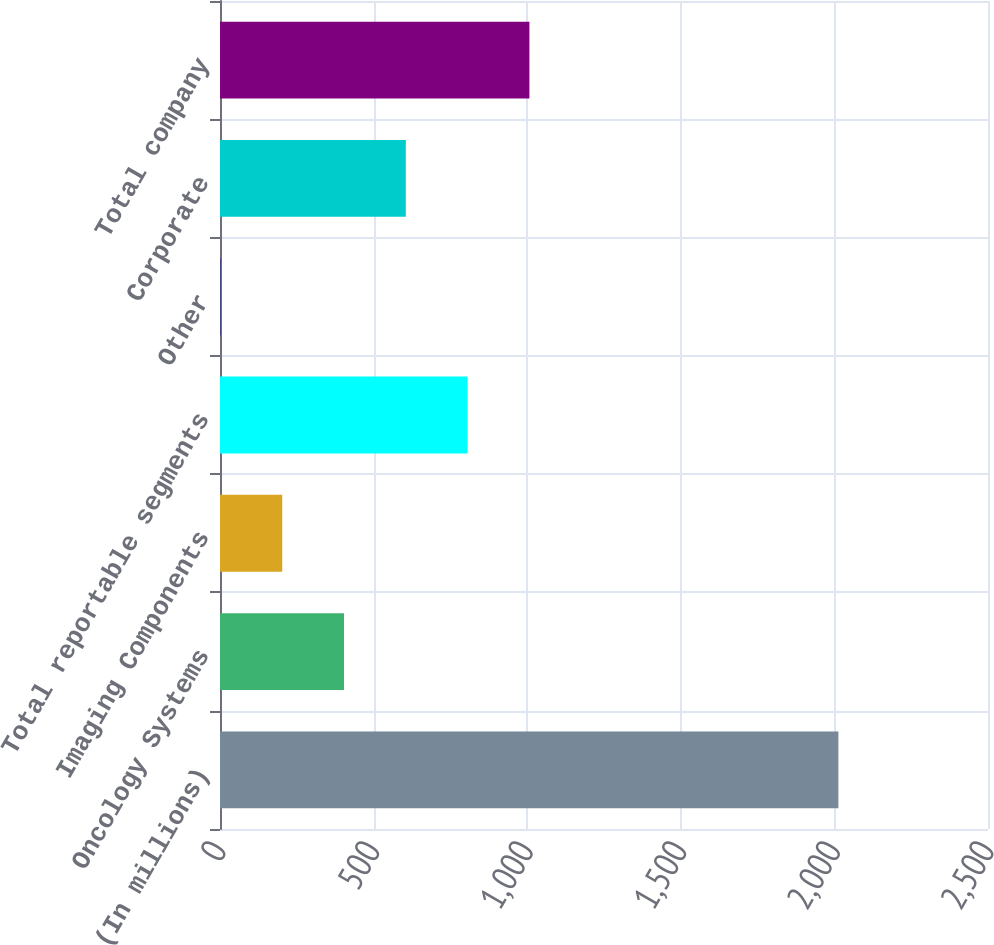Convert chart. <chart><loc_0><loc_0><loc_500><loc_500><bar_chart><fcel>(In millions)<fcel>Oncology Systems<fcel>Imaging Components<fcel>Total reportable segments<fcel>Other<fcel>Corporate<fcel>Total company<nl><fcel>2013<fcel>403.72<fcel>202.56<fcel>806.04<fcel>1.4<fcel>604.88<fcel>1007.2<nl></chart> 